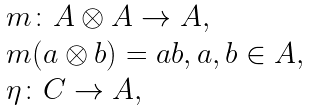<formula> <loc_0><loc_0><loc_500><loc_500>\begin{array} { r c l } & & m \colon A \otimes A \to A , \\ & & m ( a \otimes b ) = a b , a , b \in A , \\ & & \eta \colon { C } \to A , \end{array}</formula> 